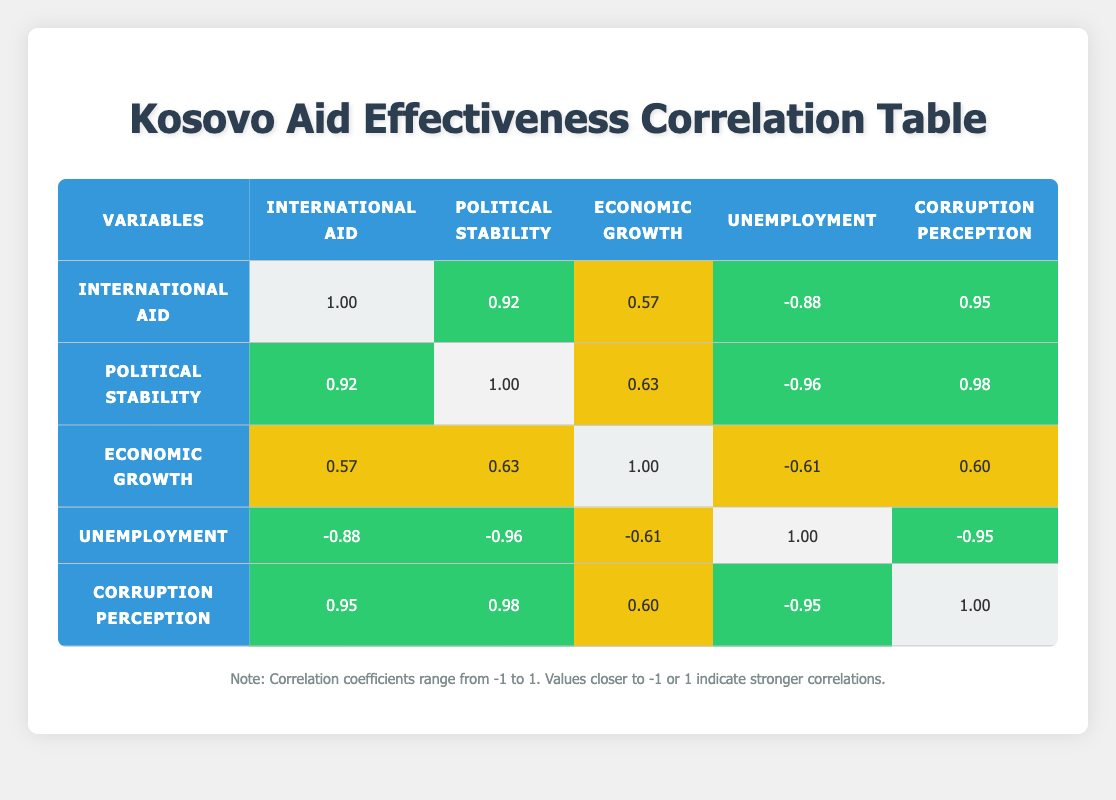What is the correlation coefficient between international aid and political stability? The correlation coefficient between international aid and political stability is found in the cell that intersects the row for international aid and the column for political stability, which is 0.92.
Answer: 0.92 How does the political stability index in 2022 compare to that in 2010? The political stability index in 2010 is 3.2 and in 2022 it is 4.6. To find the difference, subtract the 2010 value from the 2022 value: 4.6 - 3.2 = 1.4.
Answer: 1.4 What is the average unemployment rate from 2010 to 2023? To find the average unemployment rate, sum the unemployment rates from each year: (40 + 38 + 35 + 33 + 31 + 29 + 28 + 27 + 25 + 24 + 32 + 22 + 20 + 18) =  465. Then divide by the number of years (14): 465/14 = 33.21.
Answer: 33.21 Is there a significant positive correlation between international aid and the corruption perception index? To determine if there is a significant correlation, we look at the correlation value which is 0.95. Since this value is closer to 1, it indicates a strong positive correlation.
Answer: Yes What was the change in the economic growth rate from 2019 to 2020? The economic growth rate in 2019 is 3.8 and in 2020 is -1.5. To find the change, subtract the 2019 value from the 2020 value: -1.5 - 3.8 = -5.3.
Answer: -5.3 Which variable has the highest negative correlation with unemployment? From the table, we see that unemployment has the highest negative correlation with political stability, which is -0.96 (found in the row for unemployment and column for political stability).
Answer: Political stability What is the trend in international aid from 2010 to 2023? To find the trend, we can compare the values in the "international aid" column from 2010 (150) to 2023 (250). The increase from 150 to 250 indicates a positive trend over the years.
Answer: Positive trend Are there more years where the corruption perception index improved than years it decreased? By comparing the values year over year, we can see an increase in the corruption perception index from 2010 (2.5) to 2023 (4.2) without any decreases. Therefore, there are no years it decreased.
Answer: Yes What is the correlation coefficient between economic growth and corruption perception? The correlation coefficient between economic growth and corruption perception is found at the intersection of their respective rows and columns, which is 0.60.
Answer: 0.60 